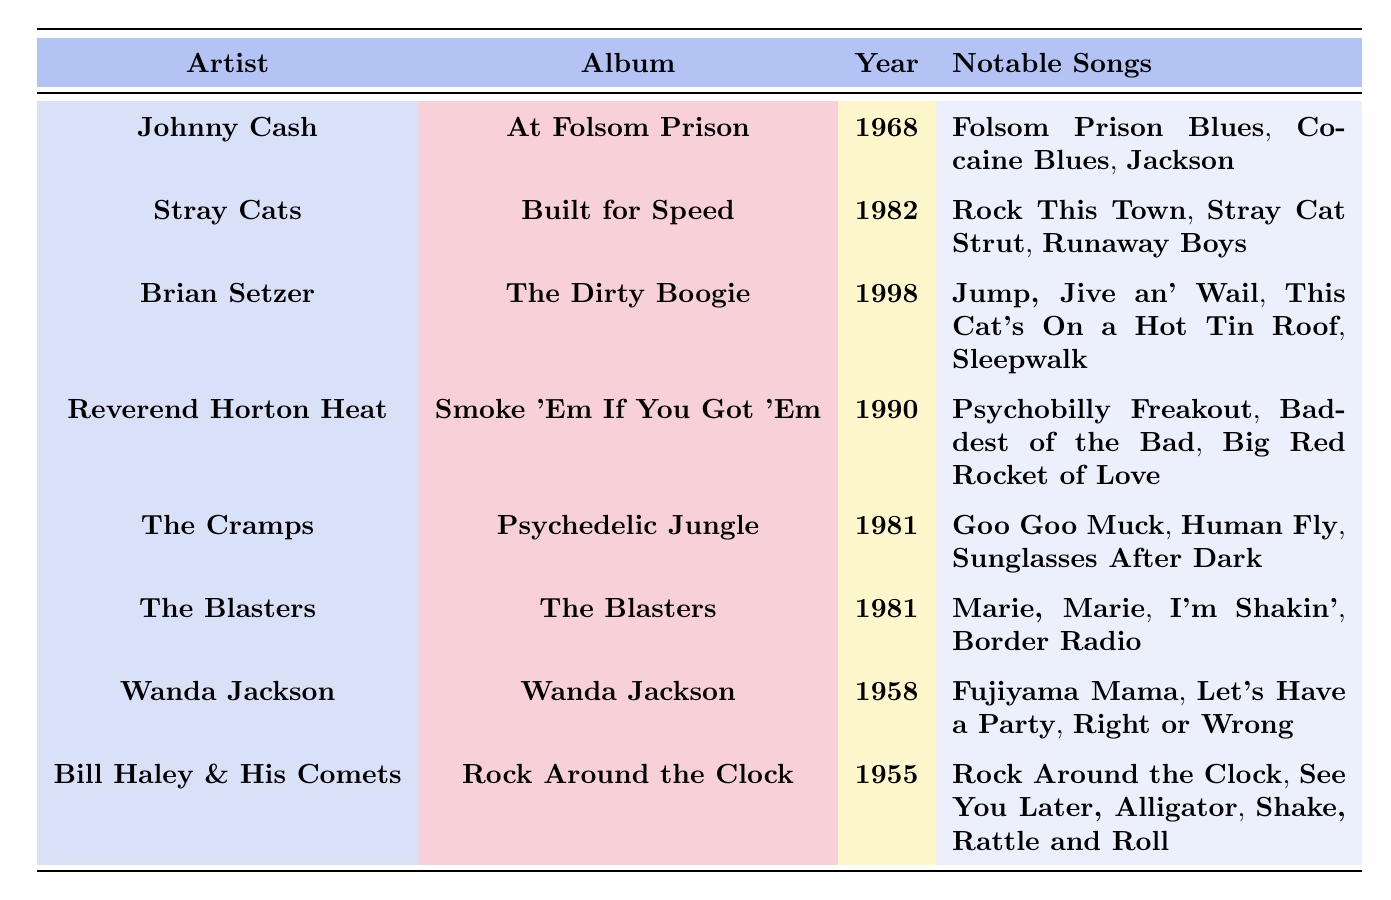What is the release year of Johnny Cash's album? The table lists Johnny Cash's album as "At Folsom Prison" and the release year is mentioned right next to it as 1968.
Answer: 1968 Which artist released their album "Built for Speed"? Looking at the table, the artist associated with the album "Built for Speed" is Stray Cats, clearly indicated in the same row.
Answer: Stray Cats How many notable songs does Brian Setzer have listed? In the row for Brian Setzer, under the "Notable Songs" column, there are three songs listed: "Jump, Jive an' Wail", "This Cat's On a Hot Tin Roof", and "Sleepwalk". Thus, the count is 3.
Answer: 3 What are the notable songs of The Cramps? The table shows the notable songs for The Cramps as listed in the "Notable Songs" column: "Goo Goo Muck", "Human Fly", and "Sunglasses After Dark".
Answer: Goo Goo Muck, Human Fly, Sunglasses After Dark Which album released in 1981 features the song "I'm Shakin'"? According to the table, The Blasters released their self-titled album "The Blasters" in 1981, which includes the song "I'm Shakin'".
Answer: The Blasters Which artist has the earliest release year? By reviewing the "Year" column in the table, Bill Haley & His Comets with the album "Rock Around the Clock" released in 1955, which is the earliest year compared to others listed.
Answer: Bill Haley & His Comets Is "Fujiyama Mama" a notable song from an album released after 1960? The song "Fujiyama Mama" is listed under Wanda Jackson's album, released in 1958, which means it is not from an album released after 1960. Thus, the statement is false.
Answer: No How do the notable songs of Reverend Horton Heat compare to those of Johnny Cash in terms of their thematic content, based on the song titles? Reverend Horton Heat’s notable songs like "Psychobilly Freakout", "Baddest of the Bad", and "Big Red Rocket of Love" suggest a more energetic, wild theme compared to Johnny Cash’s "Folsom Prison Blues", "Cocaine Blues", and "Jackson", which deal more with themes of prison life and heartache. This shows thematic diversity.
Answer: Diverse themes What is the average release year of the albums listed in the table? The release years are 1955, 1958, 1968, 1981, 1981, 1982, 1990, and 1998. Summing these gives 1955 + 1958 + 1968 + 1981 + 1981 + 1982 + 1990 + 1998 = 15813. There are 8 albums, so the average release year is 15813 / 8 = 1976.625, which rounds to approximately 1977.
Answer: 1977 How many artists listed released albums in the 1980s? Examining the table, the artists who released albums in the 1980s are Stray Cats (1982), The Cramps (1981), and The Blasters (1981), totaling three artists.
Answer: 3 